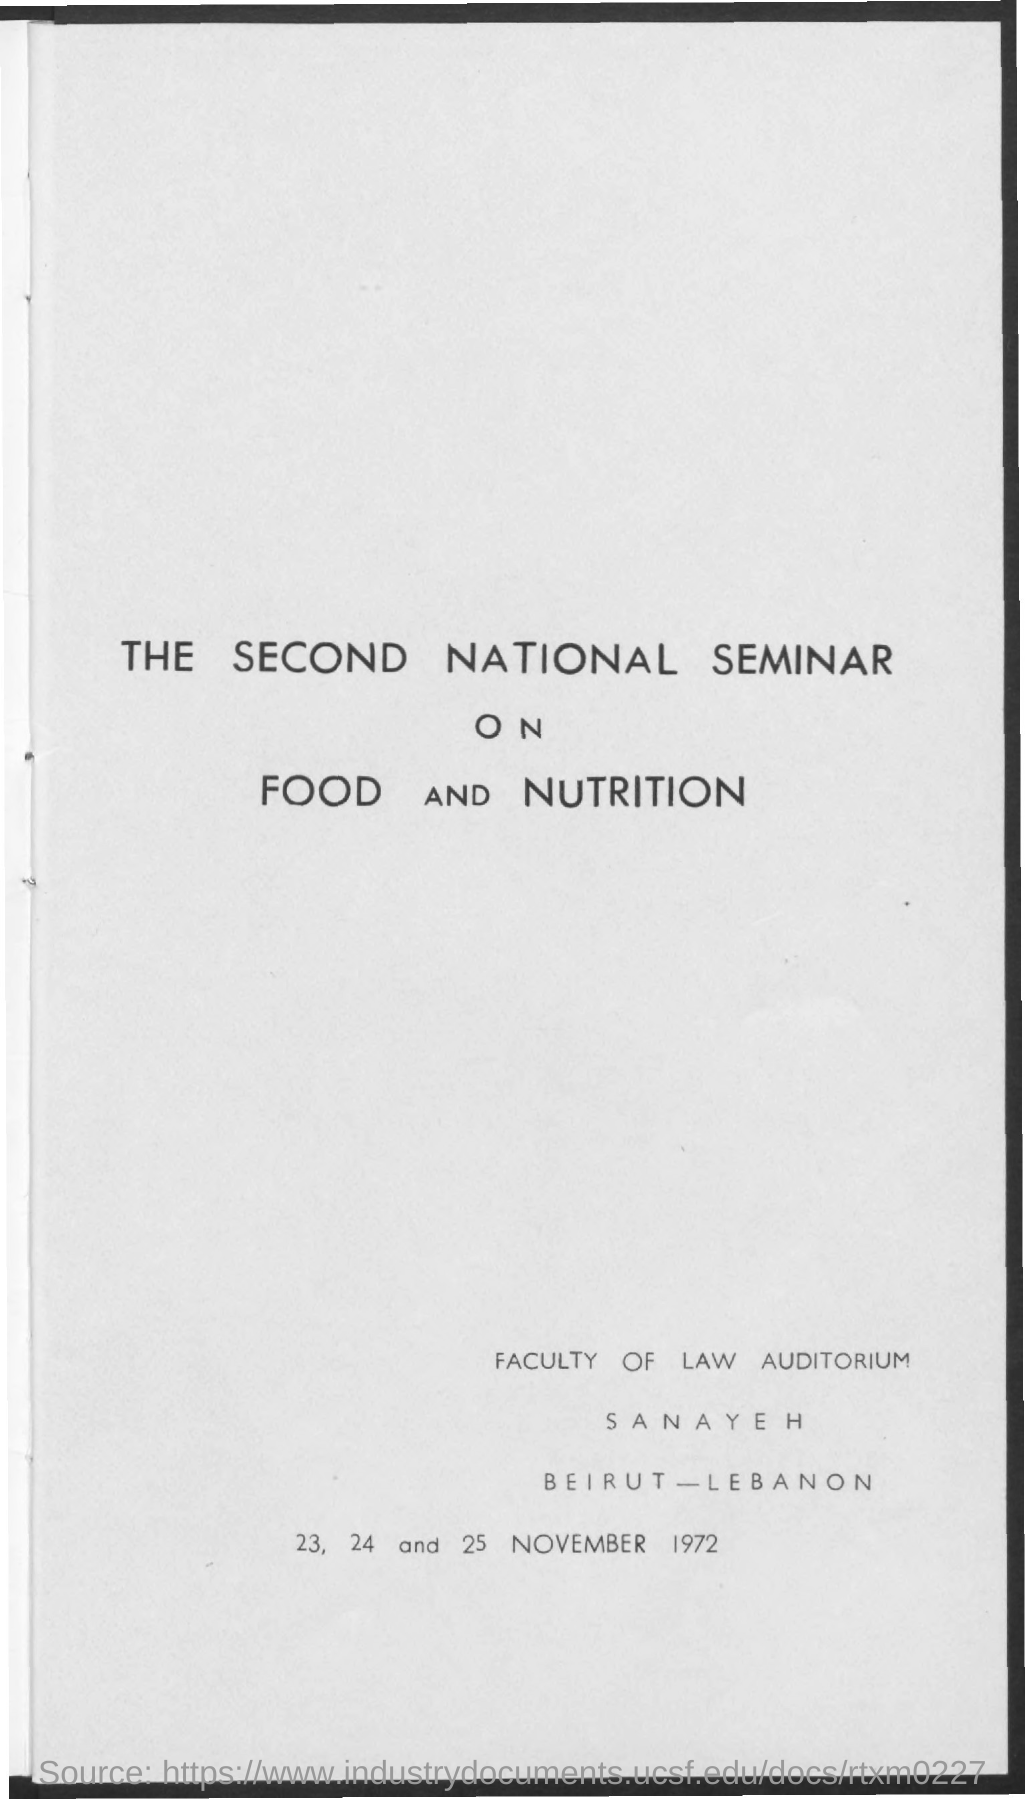What is the title of the document?
Offer a very short reply. The second national seminar on food and nutrition. 